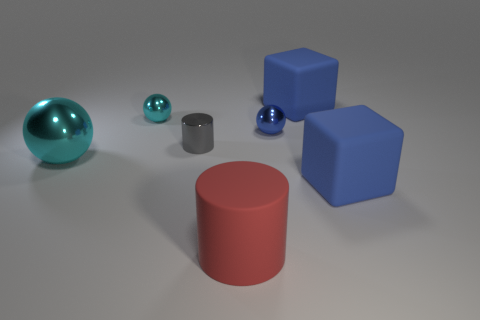Subtract all large metallic spheres. How many spheres are left? 2 Subtract all red cylinders. How many cylinders are left? 1 Add 1 matte things. How many objects exist? 8 Subtract 2 cylinders. How many cylinders are left? 0 Subtract all spheres. How many objects are left? 4 Subtract all red spheres. Subtract all cyan cylinders. How many spheres are left? 3 Subtract all yellow blocks. How many gray balls are left? 0 Subtract all big red matte cylinders. Subtract all small gray things. How many objects are left? 5 Add 5 gray shiny objects. How many gray shiny objects are left? 6 Add 7 balls. How many balls exist? 10 